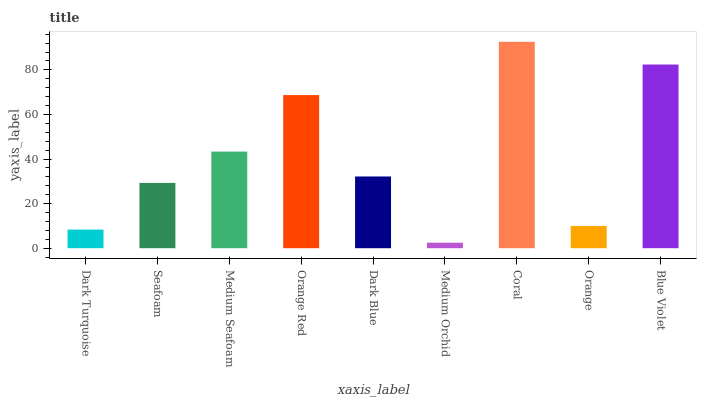Is Medium Orchid the minimum?
Answer yes or no. Yes. Is Coral the maximum?
Answer yes or no. Yes. Is Seafoam the minimum?
Answer yes or no. No. Is Seafoam the maximum?
Answer yes or no. No. Is Seafoam greater than Dark Turquoise?
Answer yes or no. Yes. Is Dark Turquoise less than Seafoam?
Answer yes or no. Yes. Is Dark Turquoise greater than Seafoam?
Answer yes or no. No. Is Seafoam less than Dark Turquoise?
Answer yes or no. No. Is Dark Blue the high median?
Answer yes or no. Yes. Is Dark Blue the low median?
Answer yes or no. Yes. Is Medium Seafoam the high median?
Answer yes or no. No. Is Medium Seafoam the low median?
Answer yes or no. No. 